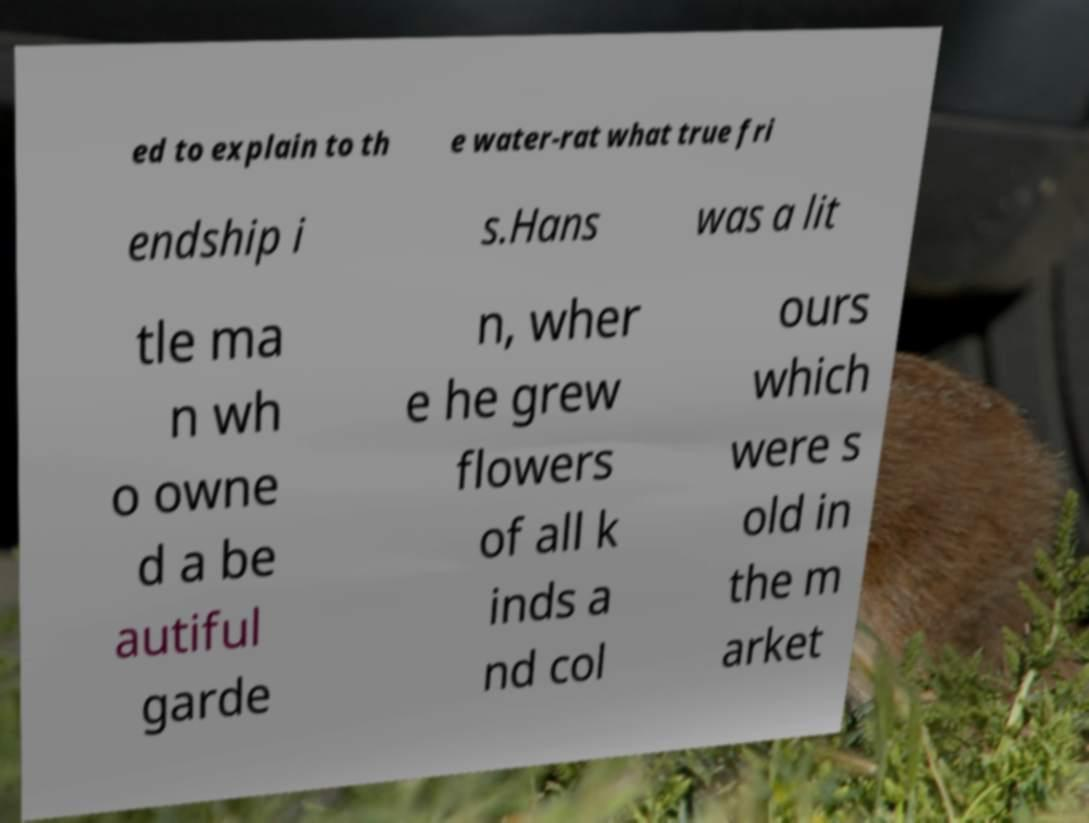Can you read and provide the text displayed in the image?This photo seems to have some interesting text. Can you extract and type it out for me? ed to explain to th e water-rat what true fri endship i s.Hans was a lit tle ma n wh o owne d a be autiful garde n, wher e he grew flowers of all k inds a nd col ours which were s old in the m arket 